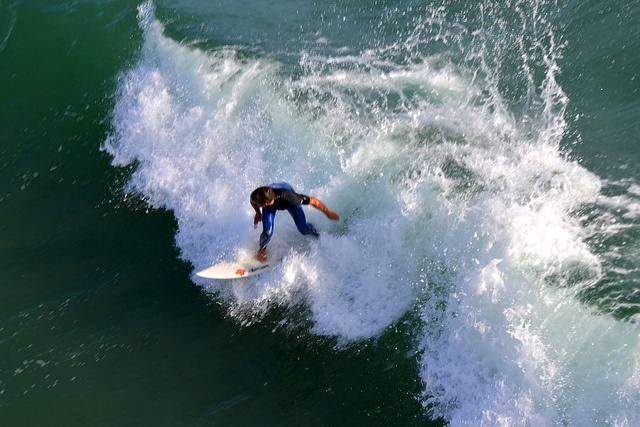Describe the objects in this image and their specific colors. I can see people in teal, black, navy, maroon, and gray tones and surfboard in teal, lightgray, darkgray, and gray tones in this image. 